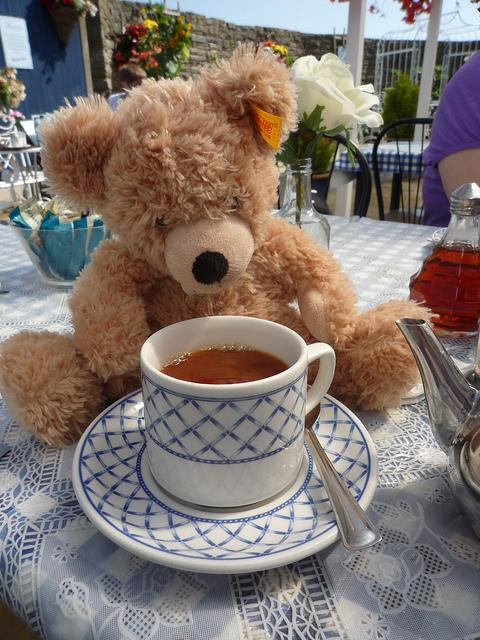Where does the teddy bear come from? child 